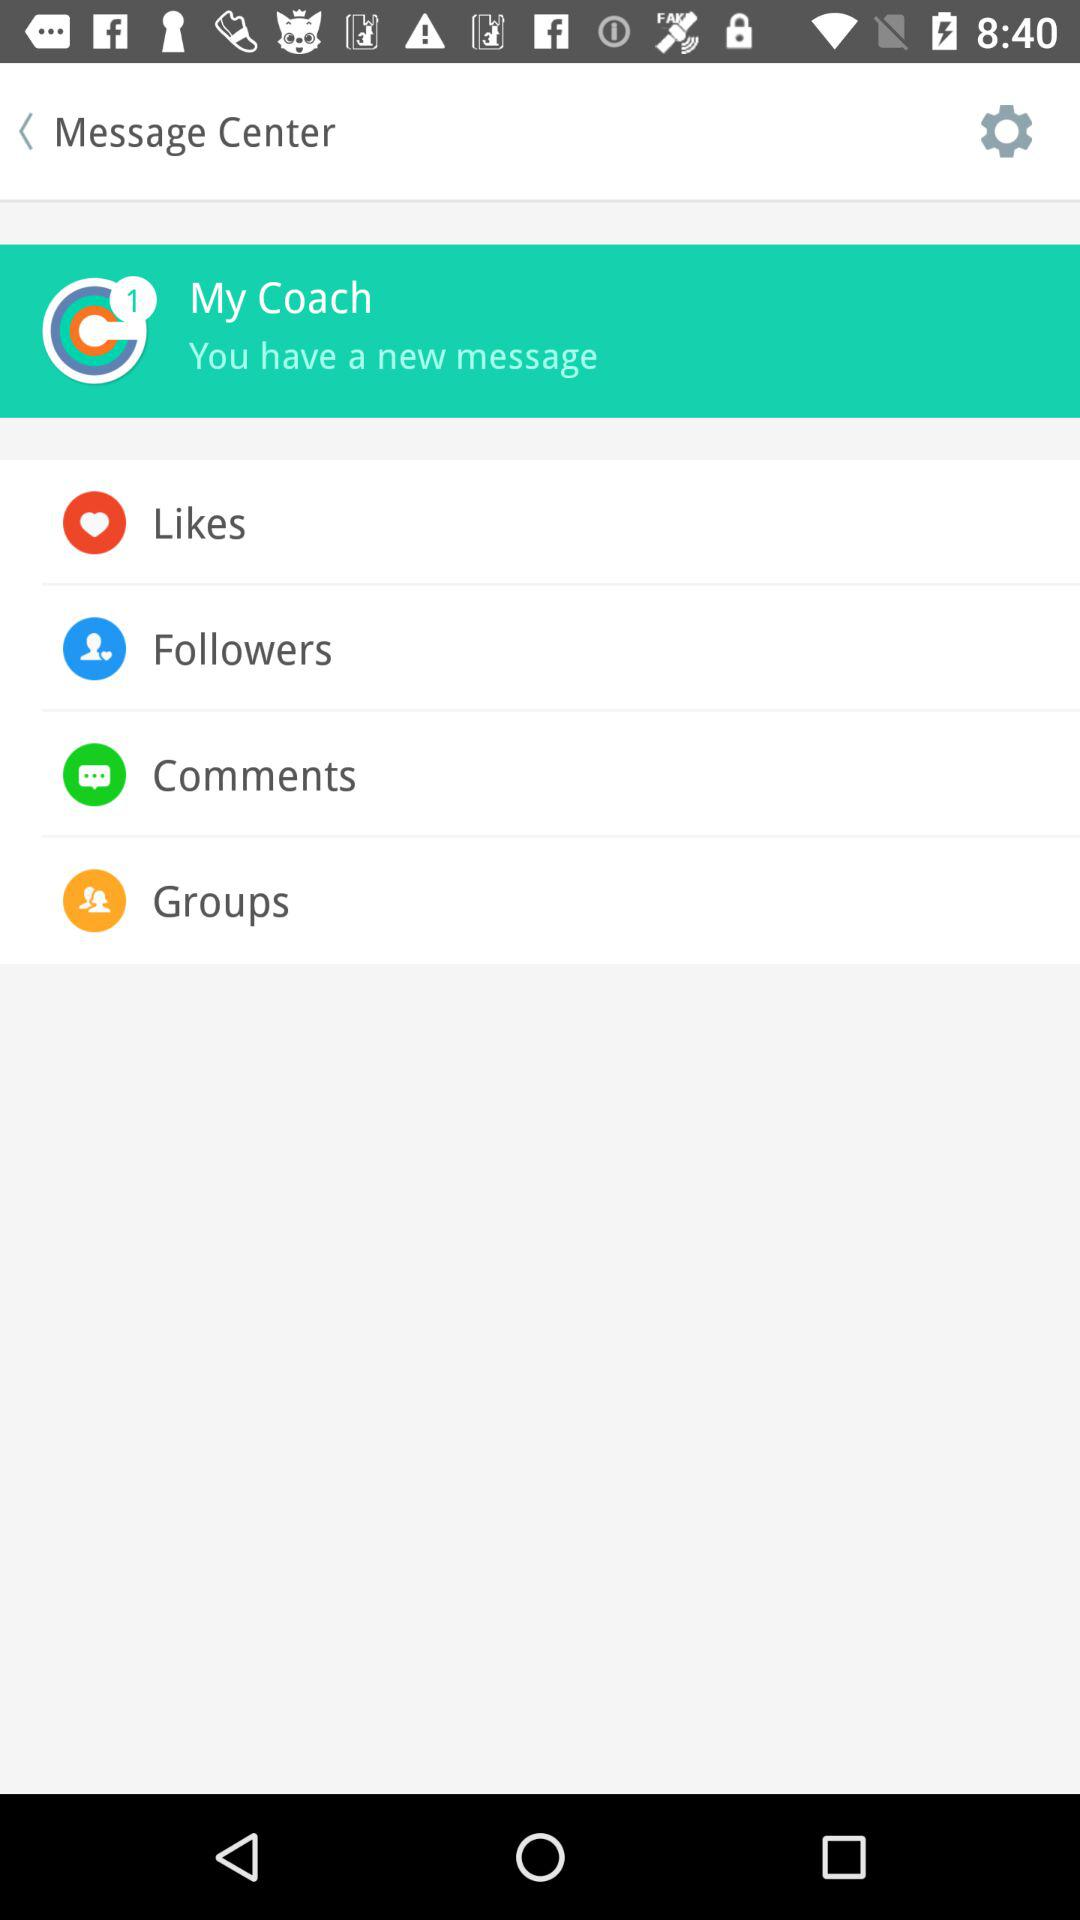How many unread messages are there? There is 1 unread message. 